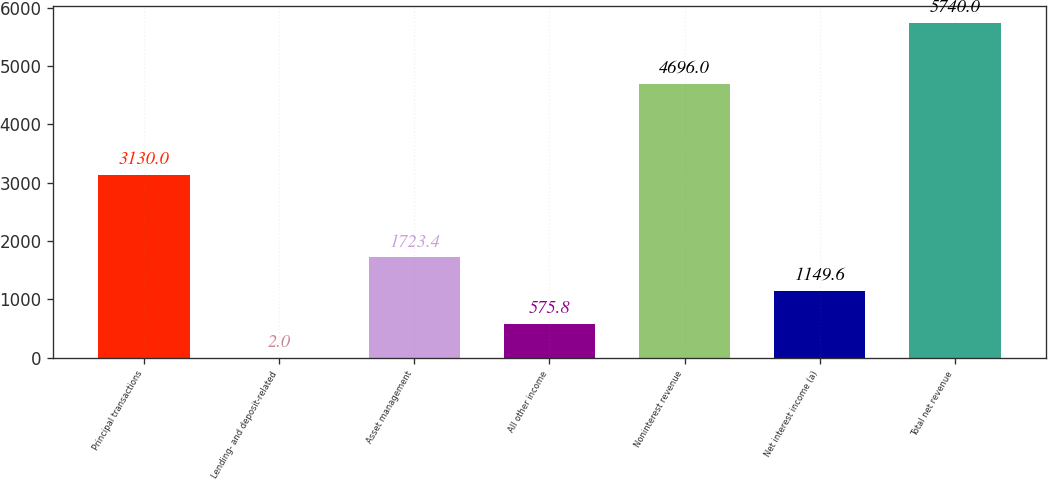<chart> <loc_0><loc_0><loc_500><loc_500><bar_chart><fcel>Principal transactions<fcel>Lending- and deposit-related<fcel>Asset management<fcel>All other income<fcel>Noninterest revenue<fcel>Net interest income (a)<fcel>Total net revenue<nl><fcel>3130<fcel>2<fcel>1723.4<fcel>575.8<fcel>4696<fcel>1149.6<fcel>5740<nl></chart> 